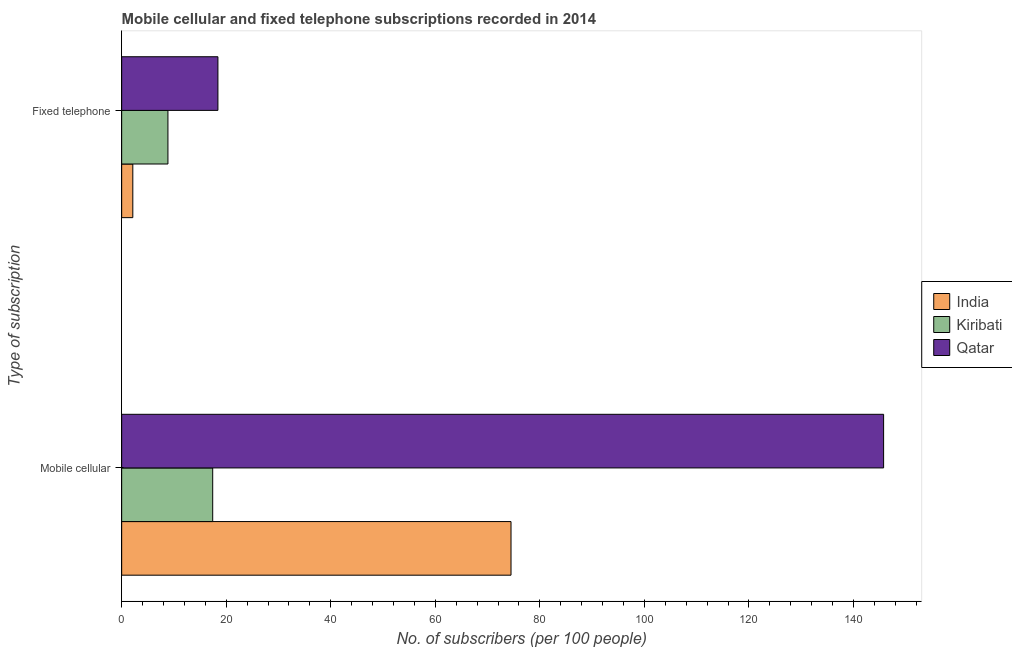How many different coloured bars are there?
Your response must be concise. 3. How many groups of bars are there?
Keep it short and to the point. 2. Are the number of bars on each tick of the Y-axis equal?
Your answer should be very brief. Yes. How many bars are there on the 1st tick from the top?
Keep it short and to the point. 3. How many bars are there on the 2nd tick from the bottom?
Provide a succinct answer. 3. What is the label of the 2nd group of bars from the top?
Give a very brief answer. Mobile cellular. What is the number of fixed telephone subscribers in India?
Keep it short and to the point. 2.13. Across all countries, what is the maximum number of mobile cellular subscribers?
Provide a short and direct response. 145.76. Across all countries, what is the minimum number of fixed telephone subscribers?
Give a very brief answer. 2.13. In which country was the number of fixed telephone subscribers maximum?
Give a very brief answer. Qatar. In which country was the number of fixed telephone subscribers minimum?
Ensure brevity in your answer.  India. What is the total number of mobile cellular subscribers in the graph?
Provide a short and direct response. 237.66. What is the difference between the number of fixed telephone subscribers in Kiribati and that in India?
Keep it short and to the point. 6.72. What is the difference between the number of mobile cellular subscribers in Kiribati and the number of fixed telephone subscribers in Qatar?
Offer a very short reply. -1. What is the average number of fixed telephone subscribers per country?
Offer a terse response. 9.8. What is the difference between the number of fixed telephone subscribers and number of mobile cellular subscribers in Qatar?
Your response must be concise. -127.35. What is the ratio of the number of mobile cellular subscribers in Qatar to that in Kiribati?
Offer a very short reply. 8.37. Is the number of mobile cellular subscribers in India less than that in Qatar?
Make the answer very short. Yes. In how many countries, is the number of mobile cellular subscribers greater than the average number of mobile cellular subscribers taken over all countries?
Give a very brief answer. 1. What does the 1st bar from the top in Mobile cellular represents?
Offer a very short reply. Qatar. Are the values on the major ticks of X-axis written in scientific E-notation?
Your answer should be compact. No. Where does the legend appear in the graph?
Your response must be concise. Center right. How many legend labels are there?
Give a very brief answer. 3. How are the legend labels stacked?
Provide a short and direct response. Vertical. What is the title of the graph?
Provide a succinct answer. Mobile cellular and fixed telephone subscriptions recorded in 2014. What is the label or title of the X-axis?
Your response must be concise. No. of subscribers (per 100 people). What is the label or title of the Y-axis?
Your answer should be compact. Type of subscription. What is the No. of subscribers (per 100 people) in India in Mobile cellular?
Your answer should be compact. 74.48. What is the No. of subscribers (per 100 people) of Kiribati in Mobile cellular?
Ensure brevity in your answer.  17.41. What is the No. of subscribers (per 100 people) of Qatar in Mobile cellular?
Provide a succinct answer. 145.76. What is the No. of subscribers (per 100 people) in India in Fixed telephone?
Offer a terse response. 2.13. What is the No. of subscribers (per 100 people) in Kiribati in Fixed telephone?
Your answer should be compact. 8.85. What is the No. of subscribers (per 100 people) in Qatar in Fixed telephone?
Provide a succinct answer. 18.41. Across all Type of subscription, what is the maximum No. of subscribers (per 100 people) of India?
Your response must be concise. 74.48. Across all Type of subscription, what is the maximum No. of subscribers (per 100 people) of Kiribati?
Your answer should be compact. 17.41. Across all Type of subscription, what is the maximum No. of subscribers (per 100 people) of Qatar?
Give a very brief answer. 145.76. Across all Type of subscription, what is the minimum No. of subscribers (per 100 people) of India?
Your response must be concise. 2.13. Across all Type of subscription, what is the minimum No. of subscribers (per 100 people) in Kiribati?
Your answer should be compact. 8.85. Across all Type of subscription, what is the minimum No. of subscribers (per 100 people) of Qatar?
Ensure brevity in your answer.  18.41. What is the total No. of subscribers (per 100 people) of India in the graph?
Offer a terse response. 76.61. What is the total No. of subscribers (per 100 people) in Kiribati in the graph?
Make the answer very short. 26.26. What is the total No. of subscribers (per 100 people) of Qatar in the graph?
Your answer should be compact. 164.18. What is the difference between the No. of subscribers (per 100 people) of India in Mobile cellular and that in Fixed telephone?
Your answer should be compact. 72.35. What is the difference between the No. of subscribers (per 100 people) of Kiribati in Mobile cellular and that in Fixed telephone?
Provide a short and direct response. 8.56. What is the difference between the No. of subscribers (per 100 people) of Qatar in Mobile cellular and that in Fixed telephone?
Provide a short and direct response. 127.35. What is the difference between the No. of subscribers (per 100 people) in India in Mobile cellular and the No. of subscribers (per 100 people) in Kiribati in Fixed telephone?
Provide a short and direct response. 65.63. What is the difference between the No. of subscribers (per 100 people) in India in Mobile cellular and the No. of subscribers (per 100 people) in Qatar in Fixed telephone?
Provide a short and direct response. 56.07. What is the difference between the No. of subscribers (per 100 people) of Kiribati in Mobile cellular and the No. of subscribers (per 100 people) of Qatar in Fixed telephone?
Give a very brief answer. -1. What is the average No. of subscribers (per 100 people) of India per Type of subscription?
Keep it short and to the point. 38.31. What is the average No. of subscribers (per 100 people) in Kiribati per Type of subscription?
Make the answer very short. 13.13. What is the average No. of subscribers (per 100 people) of Qatar per Type of subscription?
Your answer should be very brief. 82.09. What is the difference between the No. of subscribers (per 100 people) in India and No. of subscribers (per 100 people) in Kiribati in Mobile cellular?
Keep it short and to the point. 57.07. What is the difference between the No. of subscribers (per 100 people) of India and No. of subscribers (per 100 people) of Qatar in Mobile cellular?
Ensure brevity in your answer.  -71.28. What is the difference between the No. of subscribers (per 100 people) of Kiribati and No. of subscribers (per 100 people) of Qatar in Mobile cellular?
Offer a very short reply. -128.35. What is the difference between the No. of subscribers (per 100 people) in India and No. of subscribers (per 100 people) in Kiribati in Fixed telephone?
Keep it short and to the point. -6.72. What is the difference between the No. of subscribers (per 100 people) of India and No. of subscribers (per 100 people) of Qatar in Fixed telephone?
Your answer should be compact. -16.28. What is the difference between the No. of subscribers (per 100 people) in Kiribati and No. of subscribers (per 100 people) in Qatar in Fixed telephone?
Your answer should be compact. -9.56. What is the ratio of the No. of subscribers (per 100 people) in India in Mobile cellular to that in Fixed telephone?
Your answer should be very brief. 34.96. What is the ratio of the No. of subscribers (per 100 people) of Kiribati in Mobile cellular to that in Fixed telephone?
Provide a short and direct response. 1.97. What is the ratio of the No. of subscribers (per 100 people) in Qatar in Mobile cellular to that in Fixed telephone?
Your answer should be very brief. 7.92. What is the difference between the highest and the second highest No. of subscribers (per 100 people) of India?
Your response must be concise. 72.35. What is the difference between the highest and the second highest No. of subscribers (per 100 people) in Kiribati?
Your response must be concise. 8.56. What is the difference between the highest and the second highest No. of subscribers (per 100 people) of Qatar?
Your answer should be compact. 127.35. What is the difference between the highest and the lowest No. of subscribers (per 100 people) in India?
Provide a succinct answer. 72.35. What is the difference between the highest and the lowest No. of subscribers (per 100 people) of Kiribati?
Your answer should be compact. 8.56. What is the difference between the highest and the lowest No. of subscribers (per 100 people) in Qatar?
Your response must be concise. 127.35. 